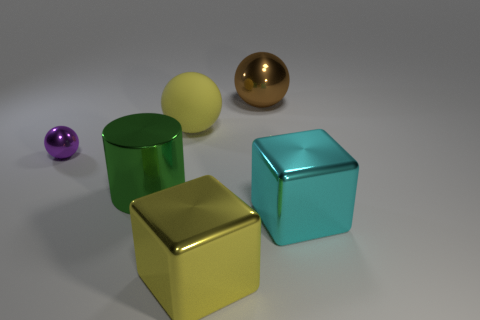Add 3 yellow matte blocks. How many objects exist? 9 Subtract all cubes. How many objects are left? 4 Add 2 metal objects. How many metal objects are left? 7 Add 1 large cyan cubes. How many large cyan cubes exist? 2 Subtract 0 brown blocks. How many objects are left? 6 Subtract all big green metallic objects. Subtract all yellow blocks. How many objects are left? 4 